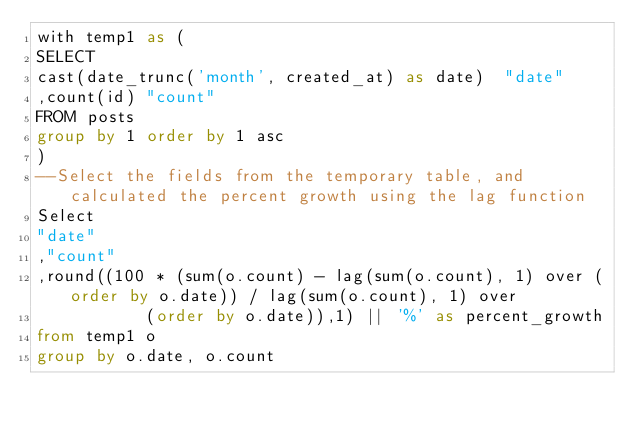Convert code to text. <code><loc_0><loc_0><loc_500><loc_500><_SQL_>with temp1 as (
SELECT 
cast(date_trunc('month', created_at) as date)  "date"
,count(id) "count"
FROM posts 
group by 1 order by 1 asc
)
--Select the fields from the temporary table, and calculated the percent growth using the lag function
Select 
"date"
,"count"
,round((100 * (sum(o.count) - lag(sum(o.count), 1) over (order by o.date)) / lag(sum(o.count), 1) over 
           (order by o.date)),1) || '%' as percent_growth
from temp1 o
group by o.date, o.count
</code> 